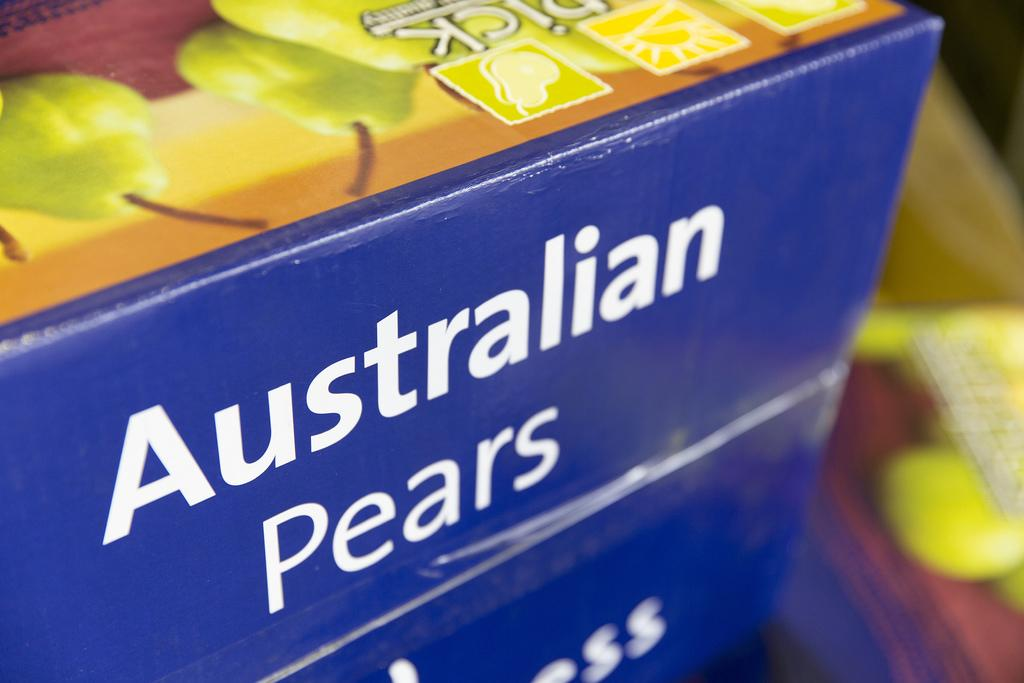What object is present in the image? There is a box in the image. What is depicted on the box? The box has pictures of pears on it. Are there any words on the box? Yes, there is text written on the box. How would you describe the clarity of the image on the right side? The right side of the image is blurry. What type of feast is being prepared in the image? There is no indication of a feast or any food preparation in the image; it primarily features a box with pictures of pears on it. 